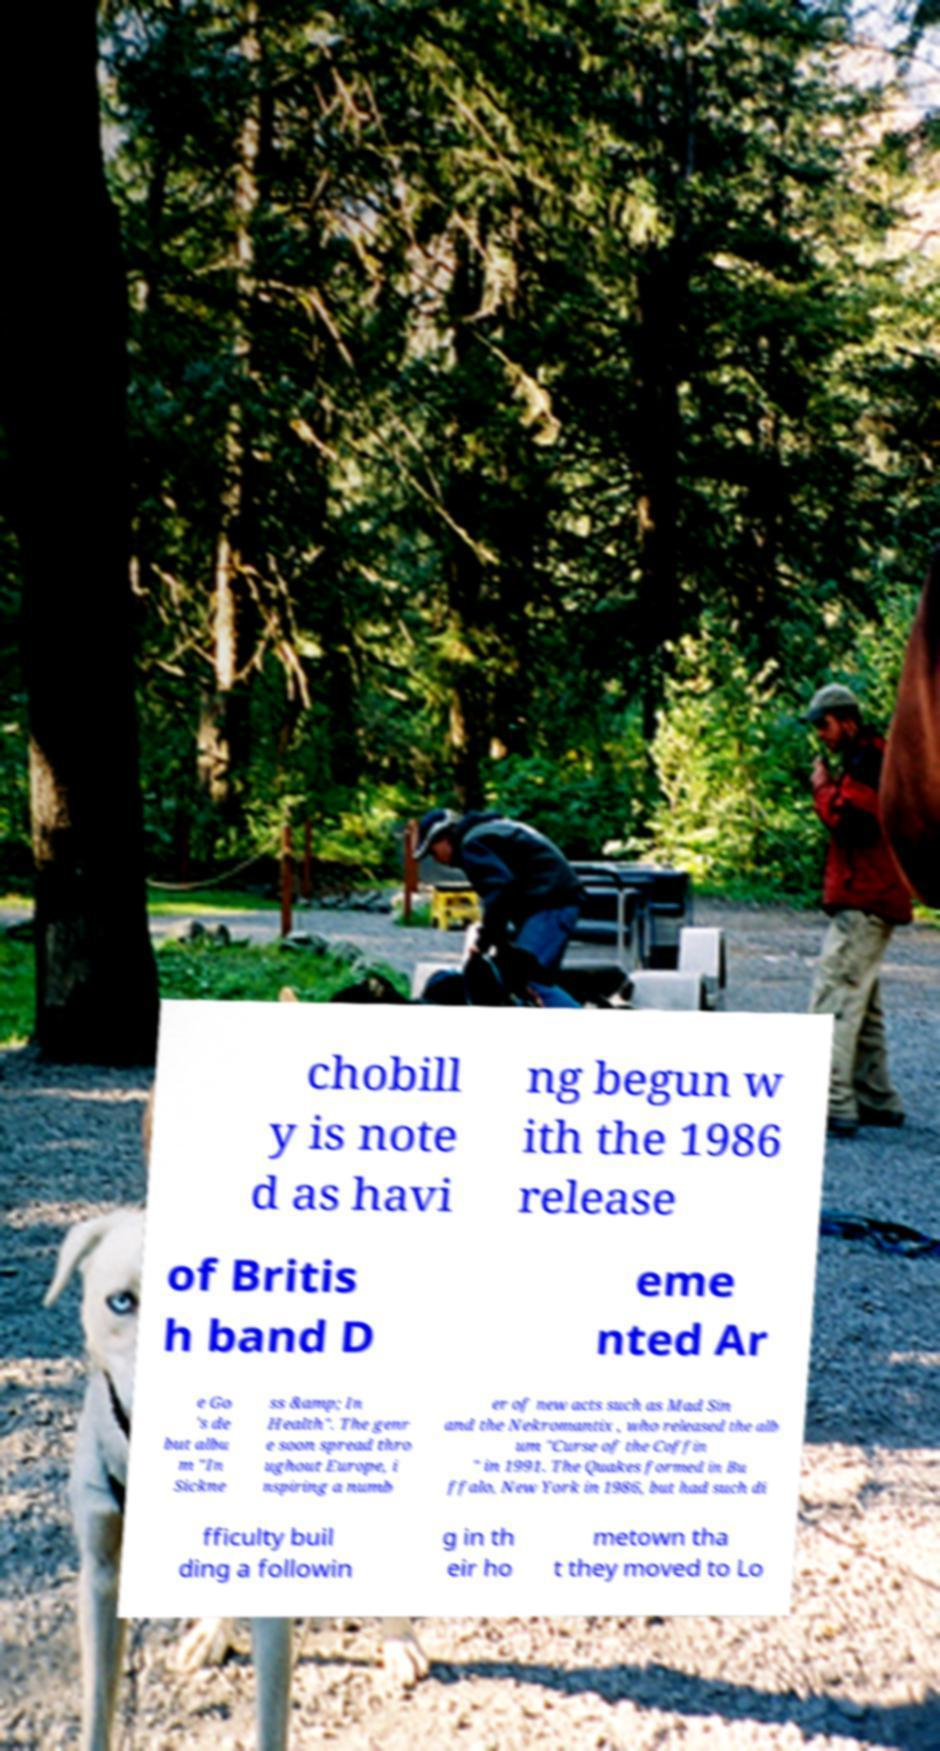For documentation purposes, I need the text within this image transcribed. Could you provide that? chobill y is note d as havi ng begun w ith the 1986 release of Britis h band D eme nted Ar e Go 's de but albu m "In Sickne ss &amp; In Health". The genr e soon spread thro ughout Europe, i nspiring a numb er of new acts such as Mad Sin and the Nekromantix , who released the alb um "Curse of the Coffin " in 1991. The Quakes formed in Bu ffalo, New York in 1986, but had such di fficulty buil ding a followin g in th eir ho metown tha t they moved to Lo 